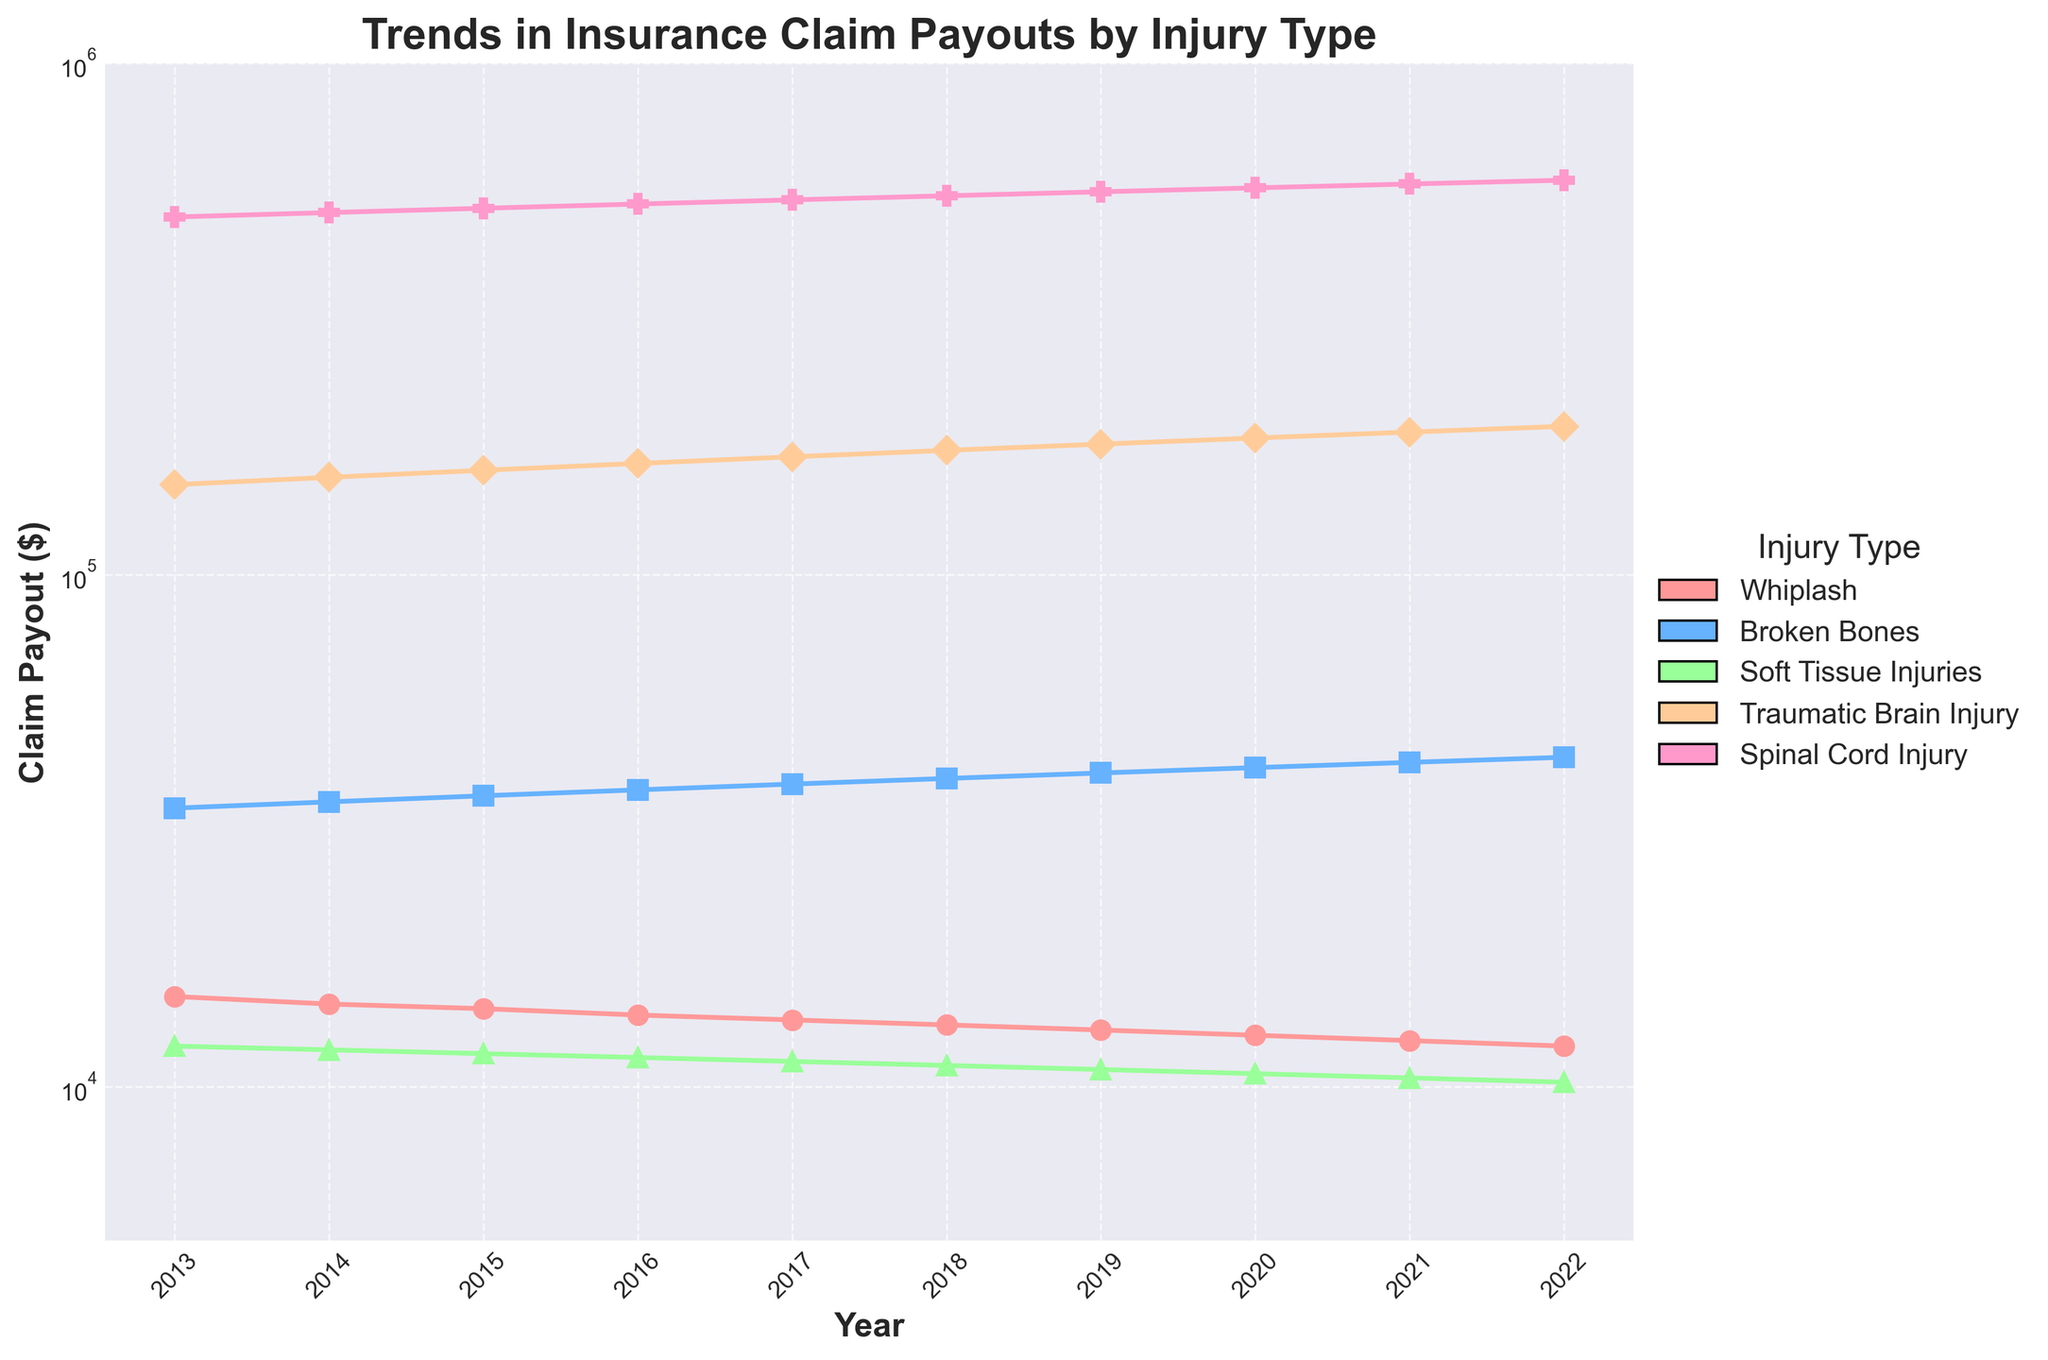Which injury type had the highest claim payout in 2022? The y-axis shows claim payouts, and the highest point in 2022 corresponds to the 'Spinal Cord Injury' line.
Answer: Spinal Cord Injury What was the trend in claim payouts for 'Whiplash' from 2013 to 2022? The 'Whiplash' line shows a consistent decrease in claim payouts over the years from 2013 to 2022.
Answer: Decreasing How much did the claim payout for 'Traumatic Brain Injury' increase from 2013 to 2022? The claim payout for 'Traumatic Brain Injury' was $150,000 in 2013 and $195,000 in 2022. The increase can be calculated as $195,000 - $150,000 = $45,000.
Answer: $45,000 Which injury type had the smallest average claim payout over the decade? To find the average, sum the yearly values for each injury type and divide by the number of years. 'Soft Tissue Injuries' consistently has the smallest yearly values.
Answer: Soft Tissue Injuries What is the difference in claim payouts between 'Broken Bones' and 'Whiplash' in 2018? In 2018, the claim payout for 'Broken Bones' was $40,000, and for 'Whiplash' it was $13,200. The difference is $40,000 - $13,200 = $26,800.
Answer: $26,800 In which year did 'Spinal Cord Injury' surpass $500,000 in claim payouts? By looking at the 'Spinal Cord Injury' line, we see it surpass $500,000 in 2013.
Answer: 2013 What can you say about the growth pattern of 'Soft Tissue Injuries' compared to 'Traumatic Brain Injury'? The 'Soft Tissue Injuries' line shows a slight, consistent decrease over time, while the 'Traumatic Brain Injury' line shows a consistent increase.
Answer: Soft Tissue Injuries: Decreasing, Traumatic Brain Injury: Increasing By what percentage did the claim payout for 'Whiplash' decrease from 2013 to 2022? In 2013 the claim payout was $15,000, and in 2022 it was $12,000. The decrease in payout amount is $15,000 - $12,000 = $3,000. The percentage decrease is ($3,000 / $15,000) * 100 = 20%.
Answer: 20% How does the magnitude of claim payouts for 'Spinal Cord Injury' compare to other injury types in 2022? The claim payout for 'Spinal Cord Injury' is significantly higher than all other injury types in 2022, as evident from its position on the y-axis.
Answer: Significantly higher 